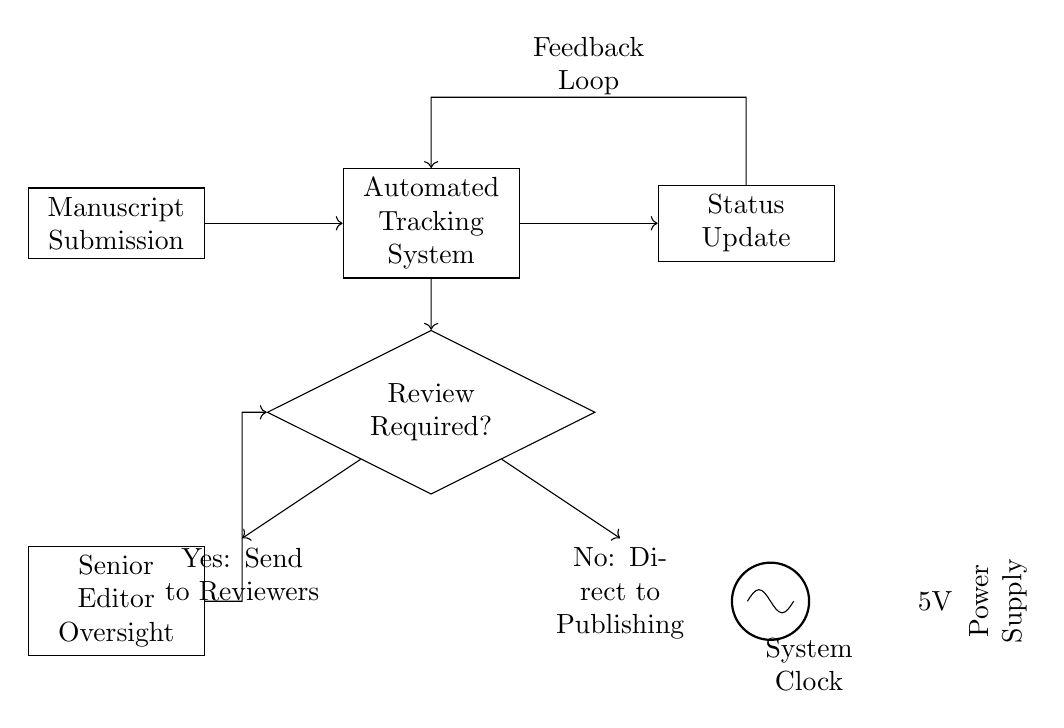What is the main input of the circuit? The main input of the circuit is "Manuscript Submission," which is represented as the starting point in the flow of the system.
Answer: Manuscript Submission What does the output component indicate? The output component indicates "Status Update," showing the result of the processing in the automated tracking system.
Answer: Status Update What is the role of the feedback loop? The feedback loop provides information back to the automated tracking system based on the output, allowing it to adjust or improve its processing.
Answer: Feedback Loop How many decision outcomes are possible in this circuit? There are two decision outcomes: "Send to Reviewers" and "Direct to Publishing," indicating the choices available after the review decision.
Answer: Two Which component demonstrates editor involvement? The component demonstrating editor involvement is "Senior Editor Oversight," indicating the editor's role in the process before the review decision.
Answer: Senior Editor Oversight What is the purpose of the system clock in this circuit? The system clock controls the timing and synchronized operation of the circuit, ensuring that functions are executed at appropriate intervals.
Answer: System Clock What is the voltage supplied to the circuit? The voltage supplied to the circuit is 5 volts, providing the necessary power for the components to function correctly.
Answer: 5 volts 